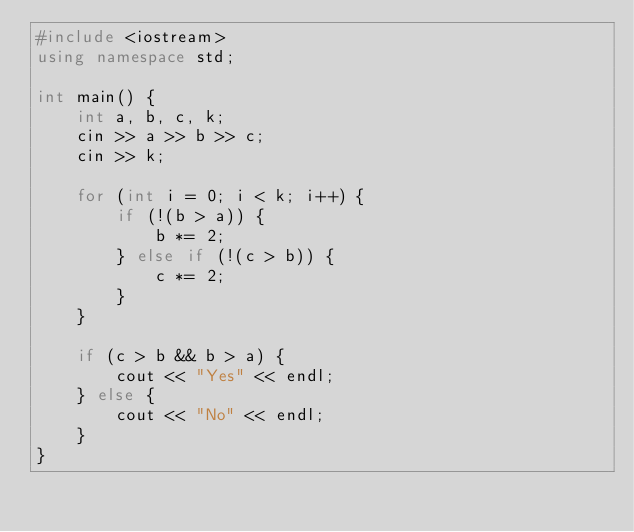<code> <loc_0><loc_0><loc_500><loc_500><_C++_>#include <iostream>
using namespace std;

int main() {
    int a, b, c, k;
    cin >> a >> b >> c;
    cin >> k;

    for (int i = 0; i < k; i++) {
        if (!(b > a)) {
            b *= 2;
        } else if (!(c > b)) {
            c *= 2;
        }
    }

    if (c > b && b > a) {
        cout << "Yes" << endl;
    } else {
        cout << "No" << endl;
    }
}</code> 